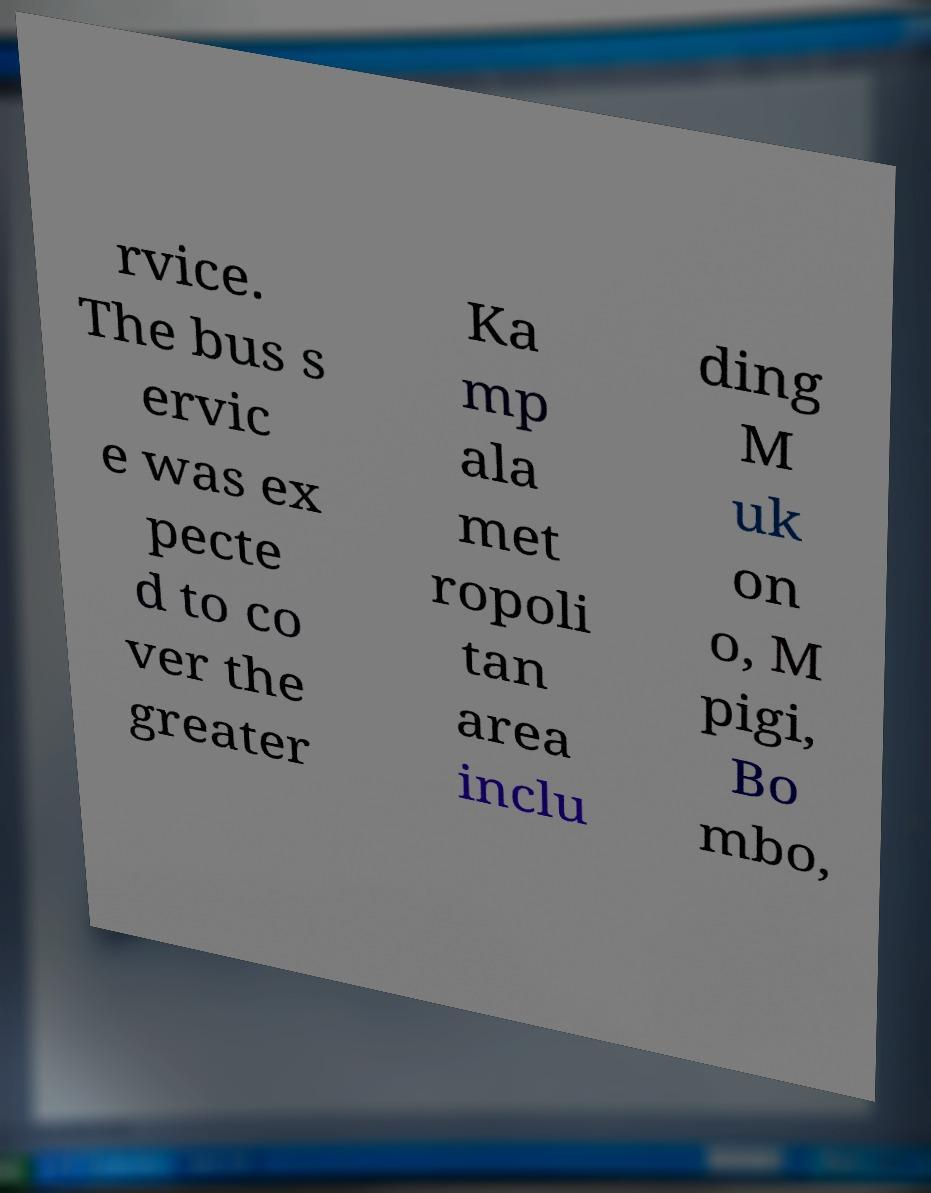I need the written content from this picture converted into text. Can you do that? rvice. The bus s ervic e was ex pecte d to co ver the greater Ka mp ala met ropoli tan area inclu ding M uk on o, M pigi, Bo mbo, 